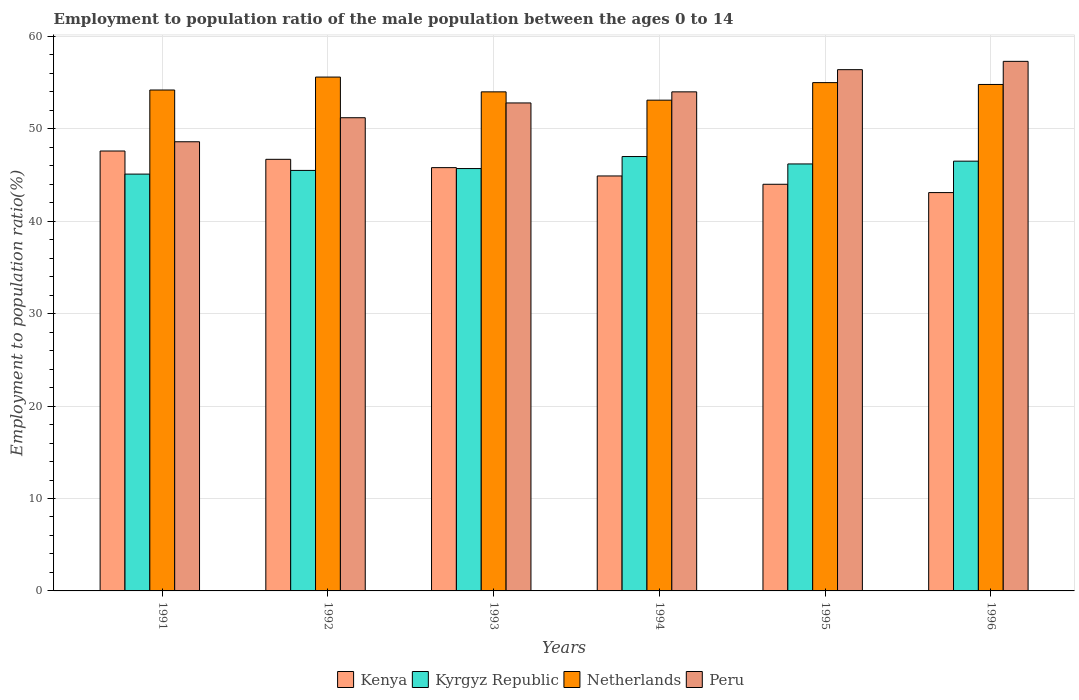How many bars are there on the 4th tick from the left?
Keep it short and to the point. 4. What is the label of the 2nd group of bars from the left?
Your response must be concise. 1992. In how many cases, is the number of bars for a given year not equal to the number of legend labels?
Provide a short and direct response. 0. What is the employment to population ratio in Kyrgyz Republic in 1992?
Provide a succinct answer. 45.5. Across all years, what is the maximum employment to population ratio in Netherlands?
Your answer should be compact. 55.6. Across all years, what is the minimum employment to population ratio in Kyrgyz Republic?
Your answer should be compact. 45.1. What is the total employment to population ratio in Kyrgyz Republic in the graph?
Keep it short and to the point. 276. What is the difference between the employment to population ratio in Netherlands in 1994 and that in 1995?
Your answer should be compact. -1.9. What is the difference between the employment to population ratio in Peru in 1992 and the employment to population ratio in Kyrgyz Republic in 1993?
Keep it short and to the point. 5.5. What is the average employment to population ratio in Kenya per year?
Offer a terse response. 45.35. In the year 1994, what is the difference between the employment to population ratio in Kenya and employment to population ratio in Netherlands?
Your answer should be compact. -8.2. In how many years, is the employment to population ratio in Kenya greater than 36 %?
Provide a succinct answer. 6. What is the ratio of the employment to population ratio in Peru in 1992 to that in 1996?
Provide a short and direct response. 0.89. Is the employment to population ratio in Kyrgyz Republic in 1991 less than that in 1994?
Your answer should be compact. Yes. Is the difference between the employment to population ratio in Kenya in 1995 and 1996 greater than the difference between the employment to population ratio in Netherlands in 1995 and 1996?
Offer a terse response. Yes. What is the difference between the highest and the second highest employment to population ratio in Peru?
Keep it short and to the point. 0.9. What is the difference between the highest and the lowest employment to population ratio in Peru?
Your response must be concise. 8.7. Is the sum of the employment to population ratio in Netherlands in 1995 and 1996 greater than the maximum employment to population ratio in Peru across all years?
Offer a terse response. Yes. Is it the case that in every year, the sum of the employment to population ratio in Kenya and employment to population ratio in Netherlands is greater than the sum of employment to population ratio in Kyrgyz Republic and employment to population ratio in Peru?
Keep it short and to the point. No. What does the 3rd bar from the left in 1994 represents?
Your response must be concise. Netherlands. What does the 1st bar from the right in 1993 represents?
Make the answer very short. Peru. What is the difference between two consecutive major ticks on the Y-axis?
Keep it short and to the point. 10. Are the values on the major ticks of Y-axis written in scientific E-notation?
Provide a short and direct response. No. Where does the legend appear in the graph?
Provide a succinct answer. Bottom center. How are the legend labels stacked?
Your response must be concise. Horizontal. What is the title of the graph?
Ensure brevity in your answer.  Employment to population ratio of the male population between the ages 0 to 14. Does "St. Vincent and the Grenadines" appear as one of the legend labels in the graph?
Your answer should be very brief. No. What is the label or title of the Y-axis?
Provide a short and direct response. Employment to population ratio(%). What is the Employment to population ratio(%) of Kenya in 1991?
Your response must be concise. 47.6. What is the Employment to population ratio(%) in Kyrgyz Republic in 1991?
Ensure brevity in your answer.  45.1. What is the Employment to population ratio(%) of Netherlands in 1991?
Offer a terse response. 54.2. What is the Employment to population ratio(%) in Peru in 1991?
Make the answer very short. 48.6. What is the Employment to population ratio(%) in Kenya in 1992?
Provide a short and direct response. 46.7. What is the Employment to population ratio(%) in Kyrgyz Republic in 1992?
Ensure brevity in your answer.  45.5. What is the Employment to population ratio(%) of Netherlands in 1992?
Give a very brief answer. 55.6. What is the Employment to population ratio(%) of Peru in 1992?
Provide a succinct answer. 51.2. What is the Employment to population ratio(%) of Kenya in 1993?
Provide a succinct answer. 45.8. What is the Employment to population ratio(%) of Kyrgyz Republic in 1993?
Keep it short and to the point. 45.7. What is the Employment to population ratio(%) in Netherlands in 1993?
Offer a very short reply. 54. What is the Employment to population ratio(%) of Peru in 1993?
Make the answer very short. 52.8. What is the Employment to population ratio(%) in Kenya in 1994?
Ensure brevity in your answer.  44.9. What is the Employment to population ratio(%) of Netherlands in 1994?
Provide a short and direct response. 53.1. What is the Employment to population ratio(%) in Peru in 1994?
Provide a succinct answer. 54. What is the Employment to population ratio(%) of Kenya in 1995?
Your answer should be very brief. 44. What is the Employment to population ratio(%) of Kyrgyz Republic in 1995?
Give a very brief answer. 46.2. What is the Employment to population ratio(%) of Peru in 1995?
Make the answer very short. 56.4. What is the Employment to population ratio(%) in Kenya in 1996?
Provide a short and direct response. 43.1. What is the Employment to population ratio(%) of Kyrgyz Republic in 1996?
Offer a terse response. 46.5. What is the Employment to population ratio(%) in Netherlands in 1996?
Keep it short and to the point. 54.8. What is the Employment to population ratio(%) in Peru in 1996?
Give a very brief answer. 57.3. Across all years, what is the maximum Employment to population ratio(%) in Kenya?
Give a very brief answer. 47.6. Across all years, what is the maximum Employment to population ratio(%) of Netherlands?
Your response must be concise. 55.6. Across all years, what is the maximum Employment to population ratio(%) of Peru?
Make the answer very short. 57.3. Across all years, what is the minimum Employment to population ratio(%) of Kenya?
Provide a succinct answer. 43.1. Across all years, what is the minimum Employment to population ratio(%) in Kyrgyz Republic?
Provide a succinct answer. 45.1. Across all years, what is the minimum Employment to population ratio(%) in Netherlands?
Ensure brevity in your answer.  53.1. Across all years, what is the minimum Employment to population ratio(%) in Peru?
Keep it short and to the point. 48.6. What is the total Employment to population ratio(%) in Kenya in the graph?
Ensure brevity in your answer.  272.1. What is the total Employment to population ratio(%) in Kyrgyz Republic in the graph?
Your response must be concise. 276. What is the total Employment to population ratio(%) of Netherlands in the graph?
Provide a short and direct response. 326.7. What is the total Employment to population ratio(%) of Peru in the graph?
Ensure brevity in your answer.  320.3. What is the difference between the Employment to population ratio(%) of Kenya in 1991 and that in 1992?
Offer a terse response. 0.9. What is the difference between the Employment to population ratio(%) of Kyrgyz Republic in 1991 and that in 1992?
Keep it short and to the point. -0.4. What is the difference between the Employment to population ratio(%) in Netherlands in 1991 and that in 1992?
Make the answer very short. -1.4. What is the difference between the Employment to population ratio(%) in Peru in 1991 and that in 1992?
Make the answer very short. -2.6. What is the difference between the Employment to population ratio(%) of Netherlands in 1991 and that in 1993?
Your answer should be compact. 0.2. What is the difference between the Employment to population ratio(%) in Kenya in 1991 and that in 1994?
Keep it short and to the point. 2.7. What is the difference between the Employment to population ratio(%) in Kenya in 1991 and that in 1995?
Your answer should be very brief. 3.6. What is the difference between the Employment to population ratio(%) in Kyrgyz Republic in 1991 and that in 1995?
Keep it short and to the point. -1.1. What is the difference between the Employment to population ratio(%) in Netherlands in 1991 and that in 1995?
Give a very brief answer. -0.8. What is the difference between the Employment to population ratio(%) of Peru in 1991 and that in 1995?
Your response must be concise. -7.8. What is the difference between the Employment to population ratio(%) in Peru in 1991 and that in 1996?
Give a very brief answer. -8.7. What is the difference between the Employment to population ratio(%) of Peru in 1992 and that in 1993?
Keep it short and to the point. -1.6. What is the difference between the Employment to population ratio(%) in Kenya in 1992 and that in 1994?
Your answer should be very brief. 1.8. What is the difference between the Employment to population ratio(%) of Peru in 1992 and that in 1994?
Ensure brevity in your answer.  -2.8. What is the difference between the Employment to population ratio(%) of Kenya in 1992 and that in 1995?
Ensure brevity in your answer.  2.7. What is the difference between the Employment to population ratio(%) in Kenya in 1992 and that in 1996?
Offer a very short reply. 3.6. What is the difference between the Employment to population ratio(%) of Kyrgyz Republic in 1992 and that in 1996?
Your response must be concise. -1. What is the difference between the Employment to population ratio(%) in Kenya in 1993 and that in 1994?
Your response must be concise. 0.9. What is the difference between the Employment to population ratio(%) of Kyrgyz Republic in 1993 and that in 1994?
Your response must be concise. -1.3. What is the difference between the Employment to population ratio(%) of Peru in 1993 and that in 1994?
Offer a very short reply. -1.2. What is the difference between the Employment to population ratio(%) of Netherlands in 1993 and that in 1995?
Make the answer very short. -1. What is the difference between the Employment to population ratio(%) in Kenya in 1993 and that in 1996?
Provide a short and direct response. 2.7. What is the difference between the Employment to population ratio(%) of Kyrgyz Republic in 1993 and that in 1996?
Keep it short and to the point. -0.8. What is the difference between the Employment to population ratio(%) of Kyrgyz Republic in 1994 and that in 1995?
Provide a succinct answer. 0.8. What is the difference between the Employment to population ratio(%) of Netherlands in 1994 and that in 1996?
Offer a terse response. -1.7. What is the difference between the Employment to population ratio(%) in Peru in 1994 and that in 1996?
Make the answer very short. -3.3. What is the difference between the Employment to population ratio(%) of Kyrgyz Republic in 1995 and that in 1996?
Give a very brief answer. -0.3. What is the difference between the Employment to population ratio(%) of Peru in 1995 and that in 1996?
Ensure brevity in your answer.  -0.9. What is the difference between the Employment to population ratio(%) of Kenya in 1991 and the Employment to population ratio(%) of Netherlands in 1992?
Keep it short and to the point. -8. What is the difference between the Employment to population ratio(%) of Kenya in 1991 and the Employment to population ratio(%) of Peru in 1993?
Offer a very short reply. -5.2. What is the difference between the Employment to population ratio(%) in Kyrgyz Republic in 1991 and the Employment to population ratio(%) in Netherlands in 1993?
Ensure brevity in your answer.  -8.9. What is the difference between the Employment to population ratio(%) in Netherlands in 1991 and the Employment to population ratio(%) in Peru in 1993?
Make the answer very short. 1.4. What is the difference between the Employment to population ratio(%) in Kenya in 1991 and the Employment to population ratio(%) in Peru in 1994?
Your response must be concise. -6.4. What is the difference between the Employment to population ratio(%) in Kyrgyz Republic in 1991 and the Employment to population ratio(%) in Peru in 1994?
Your answer should be compact. -8.9. What is the difference between the Employment to population ratio(%) in Netherlands in 1991 and the Employment to population ratio(%) in Peru in 1994?
Your answer should be compact. 0.2. What is the difference between the Employment to population ratio(%) of Kenya in 1991 and the Employment to population ratio(%) of Kyrgyz Republic in 1995?
Give a very brief answer. 1.4. What is the difference between the Employment to population ratio(%) in Netherlands in 1991 and the Employment to population ratio(%) in Peru in 1995?
Make the answer very short. -2.2. What is the difference between the Employment to population ratio(%) in Kenya in 1991 and the Employment to population ratio(%) in Netherlands in 1996?
Offer a terse response. -7.2. What is the difference between the Employment to population ratio(%) in Kenya in 1991 and the Employment to population ratio(%) in Peru in 1996?
Give a very brief answer. -9.7. What is the difference between the Employment to population ratio(%) in Kyrgyz Republic in 1991 and the Employment to population ratio(%) in Peru in 1996?
Ensure brevity in your answer.  -12.2. What is the difference between the Employment to population ratio(%) of Netherlands in 1991 and the Employment to population ratio(%) of Peru in 1996?
Ensure brevity in your answer.  -3.1. What is the difference between the Employment to population ratio(%) in Kenya in 1992 and the Employment to population ratio(%) in Netherlands in 1993?
Ensure brevity in your answer.  -7.3. What is the difference between the Employment to population ratio(%) of Kyrgyz Republic in 1992 and the Employment to population ratio(%) of Netherlands in 1993?
Make the answer very short. -8.5. What is the difference between the Employment to population ratio(%) in Netherlands in 1992 and the Employment to population ratio(%) in Peru in 1993?
Provide a short and direct response. 2.8. What is the difference between the Employment to population ratio(%) of Kenya in 1992 and the Employment to population ratio(%) of Kyrgyz Republic in 1994?
Provide a short and direct response. -0.3. What is the difference between the Employment to population ratio(%) in Kyrgyz Republic in 1992 and the Employment to population ratio(%) in Netherlands in 1995?
Keep it short and to the point. -9.5. What is the difference between the Employment to population ratio(%) of Netherlands in 1992 and the Employment to population ratio(%) of Peru in 1995?
Your response must be concise. -0.8. What is the difference between the Employment to population ratio(%) in Kenya in 1992 and the Employment to population ratio(%) in Kyrgyz Republic in 1996?
Offer a very short reply. 0.2. What is the difference between the Employment to population ratio(%) in Kyrgyz Republic in 1992 and the Employment to population ratio(%) in Peru in 1996?
Ensure brevity in your answer.  -11.8. What is the difference between the Employment to population ratio(%) in Kyrgyz Republic in 1993 and the Employment to population ratio(%) in Peru in 1994?
Provide a succinct answer. -8.3. What is the difference between the Employment to population ratio(%) in Netherlands in 1993 and the Employment to population ratio(%) in Peru in 1994?
Provide a succinct answer. 0. What is the difference between the Employment to population ratio(%) of Kenya in 1993 and the Employment to population ratio(%) of Kyrgyz Republic in 1995?
Make the answer very short. -0.4. What is the difference between the Employment to population ratio(%) of Kenya in 1993 and the Employment to population ratio(%) of Peru in 1995?
Offer a very short reply. -10.6. What is the difference between the Employment to population ratio(%) of Kyrgyz Republic in 1993 and the Employment to population ratio(%) of Peru in 1995?
Keep it short and to the point. -10.7. What is the difference between the Employment to population ratio(%) of Kenya in 1993 and the Employment to population ratio(%) of Peru in 1996?
Provide a succinct answer. -11.5. What is the difference between the Employment to population ratio(%) in Netherlands in 1993 and the Employment to population ratio(%) in Peru in 1996?
Provide a succinct answer. -3.3. What is the difference between the Employment to population ratio(%) in Kenya in 1994 and the Employment to population ratio(%) in Kyrgyz Republic in 1995?
Your answer should be very brief. -1.3. What is the difference between the Employment to population ratio(%) in Kenya in 1994 and the Employment to population ratio(%) in Netherlands in 1995?
Your response must be concise. -10.1. What is the difference between the Employment to population ratio(%) of Kyrgyz Republic in 1994 and the Employment to population ratio(%) of Netherlands in 1995?
Keep it short and to the point. -8. What is the difference between the Employment to population ratio(%) in Kyrgyz Republic in 1994 and the Employment to population ratio(%) in Peru in 1995?
Offer a very short reply. -9.4. What is the difference between the Employment to population ratio(%) of Netherlands in 1994 and the Employment to population ratio(%) of Peru in 1995?
Make the answer very short. -3.3. What is the difference between the Employment to population ratio(%) of Kenya in 1994 and the Employment to population ratio(%) of Kyrgyz Republic in 1996?
Your answer should be compact. -1.6. What is the difference between the Employment to population ratio(%) in Kenya in 1994 and the Employment to population ratio(%) in Peru in 1996?
Ensure brevity in your answer.  -12.4. What is the difference between the Employment to population ratio(%) of Kyrgyz Republic in 1994 and the Employment to population ratio(%) of Netherlands in 1996?
Provide a short and direct response. -7.8. What is the difference between the Employment to population ratio(%) in Netherlands in 1994 and the Employment to population ratio(%) in Peru in 1996?
Provide a succinct answer. -4.2. What is the difference between the Employment to population ratio(%) in Kenya in 1995 and the Employment to population ratio(%) in Kyrgyz Republic in 1996?
Ensure brevity in your answer.  -2.5. What is the difference between the Employment to population ratio(%) in Kenya in 1995 and the Employment to population ratio(%) in Peru in 1996?
Offer a terse response. -13.3. What is the average Employment to population ratio(%) in Kenya per year?
Your response must be concise. 45.35. What is the average Employment to population ratio(%) of Netherlands per year?
Your response must be concise. 54.45. What is the average Employment to population ratio(%) in Peru per year?
Ensure brevity in your answer.  53.38. In the year 1991, what is the difference between the Employment to population ratio(%) in Kenya and Employment to population ratio(%) in Kyrgyz Republic?
Give a very brief answer. 2.5. In the year 1991, what is the difference between the Employment to population ratio(%) of Kenya and Employment to population ratio(%) of Netherlands?
Make the answer very short. -6.6. In the year 1991, what is the difference between the Employment to population ratio(%) of Kenya and Employment to population ratio(%) of Peru?
Ensure brevity in your answer.  -1. In the year 1992, what is the difference between the Employment to population ratio(%) in Kyrgyz Republic and Employment to population ratio(%) in Netherlands?
Make the answer very short. -10.1. In the year 1992, what is the difference between the Employment to population ratio(%) in Kyrgyz Republic and Employment to population ratio(%) in Peru?
Offer a very short reply. -5.7. In the year 1992, what is the difference between the Employment to population ratio(%) of Netherlands and Employment to population ratio(%) of Peru?
Offer a very short reply. 4.4. In the year 1993, what is the difference between the Employment to population ratio(%) of Kenya and Employment to population ratio(%) of Kyrgyz Republic?
Offer a very short reply. 0.1. In the year 1993, what is the difference between the Employment to population ratio(%) of Kyrgyz Republic and Employment to population ratio(%) of Netherlands?
Offer a terse response. -8.3. In the year 1994, what is the difference between the Employment to population ratio(%) of Netherlands and Employment to population ratio(%) of Peru?
Your answer should be compact. -0.9. In the year 1995, what is the difference between the Employment to population ratio(%) in Kenya and Employment to population ratio(%) in Kyrgyz Republic?
Ensure brevity in your answer.  -2.2. In the year 1995, what is the difference between the Employment to population ratio(%) of Kenya and Employment to population ratio(%) of Peru?
Give a very brief answer. -12.4. In the year 1995, what is the difference between the Employment to population ratio(%) in Kyrgyz Republic and Employment to population ratio(%) in Netherlands?
Keep it short and to the point. -8.8. In the year 1995, what is the difference between the Employment to population ratio(%) in Kyrgyz Republic and Employment to population ratio(%) in Peru?
Keep it short and to the point. -10.2. In the year 1996, what is the difference between the Employment to population ratio(%) of Kenya and Employment to population ratio(%) of Kyrgyz Republic?
Give a very brief answer. -3.4. In the year 1996, what is the difference between the Employment to population ratio(%) of Kenya and Employment to population ratio(%) of Peru?
Make the answer very short. -14.2. In the year 1996, what is the difference between the Employment to population ratio(%) of Kyrgyz Republic and Employment to population ratio(%) of Peru?
Keep it short and to the point. -10.8. What is the ratio of the Employment to population ratio(%) in Kenya in 1991 to that in 1992?
Offer a very short reply. 1.02. What is the ratio of the Employment to population ratio(%) in Netherlands in 1991 to that in 1992?
Provide a succinct answer. 0.97. What is the ratio of the Employment to population ratio(%) of Peru in 1991 to that in 1992?
Your answer should be compact. 0.95. What is the ratio of the Employment to population ratio(%) in Kenya in 1991 to that in 1993?
Offer a very short reply. 1.04. What is the ratio of the Employment to population ratio(%) in Kyrgyz Republic in 1991 to that in 1993?
Provide a succinct answer. 0.99. What is the ratio of the Employment to population ratio(%) in Peru in 1991 to that in 1993?
Offer a terse response. 0.92. What is the ratio of the Employment to population ratio(%) in Kenya in 1991 to that in 1994?
Provide a short and direct response. 1.06. What is the ratio of the Employment to population ratio(%) of Kyrgyz Republic in 1991 to that in 1994?
Ensure brevity in your answer.  0.96. What is the ratio of the Employment to population ratio(%) in Netherlands in 1991 to that in 1994?
Offer a very short reply. 1.02. What is the ratio of the Employment to population ratio(%) of Kenya in 1991 to that in 1995?
Keep it short and to the point. 1.08. What is the ratio of the Employment to population ratio(%) in Kyrgyz Republic in 1991 to that in 1995?
Offer a terse response. 0.98. What is the ratio of the Employment to population ratio(%) of Netherlands in 1991 to that in 1995?
Offer a very short reply. 0.99. What is the ratio of the Employment to population ratio(%) in Peru in 1991 to that in 1995?
Offer a very short reply. 0.86. What is the ratio of the Employment to population ratio(%) in Kenya in 1991 to that in 1996?
Make the answer very short. 1.1. What is the ratio of the Employment to population ratio(%) in Kyrgyz Republic in 1991 to that in 1996?
Provide a short and direct response. 0.97. What is the ratio of the Employment to population ratio(%) of Netherlands in 1991 to that in 1996?
Your answer should be very brief. 0.99. What is the ratio of the Employment to population ratio(%) of Peru in 1991 to that in 1996?
Your answer should be very brief. 0.85. What is the ratio of the Employment to population ratio(%) of Kenya in 1992 to that in 1993?
Offer a terse response. 1.02. What is the ratio of the Employment to population ratio(%) in Kyrgyz Republic in 1992 to that in 1993?
Keep it short and to the point. 1. What is the ratio of the Employment to population ratio(%) of Netherlands in 1992 to that in 1993?
Ensure brevity in your answer.  1.03. What is the ratio of the Employment to population ratio(%) of Peru in 1992 to that in 1993?
Your answer should be very brief. 0.97. What is the ratio of the Employment to population ratio(%) of Kenya in 1992 to that in 1994?
Your answer should be very brief. 1.04. What is the ratio of the Employment to population ratio(%) in Kyrgyz Republic in 1992 to that in 1994?
Provide a short and direct response. 0.97. What is the ratio of the Employment to population ratio(%) of Netherlands in 1992 to that in 1994?
Offer a terse response. 1.05. What is the ratio of the Employment to population ratio(%) in Peru in 1992 to that in 1994?
Offer a very short reply. 0.95. What is the ratio of the Employment to population ratio(%) in Kenya in 1992 to that in 1995?
Your answer should be compact. 1.06. What is the ratio of the Employment to population ratio(%) of Netherlands in 1992 to that in 1995?
Keep it short and to the point. 1.01. What is the ratio of the Employment to population ratio(%) of Peru in 1992 to that in 1995?
Give a very brief answer. 0.91. What is the ratio of the Employment to population ratio(%) of Kenya in 1992 to that in 1996?
Your answer should be compact. 1.08. What is the ratio of the Employment to population ratio(%) of Kyrgyz Republic in 1992 to that in 1996?
Provide a succinct answer. 0.98. What is the ratio of the Employment to population ratio(%) of Netherlands in 1992 to that in 1996?
Keep it short and to the point. 1.01. What is the ratio of the Employment to population ratio(%) in Peru in 1992 to that in 1996?
Offer a very short reply. 0.89. What is the ratio of the Employment to population ratio(%) of Kenya in 1993 to that in 1994?
Your response must be concise. 1.02. What is the ratio of the Employment to population ratio(%) in Kyrgyz Republic in 1993 to that in 1994?
Offer a terse response. 0.97. What is the ratio of the Employment to population ratio(%) in Netherlands in 1993 to that in 1994?
Make the answer very short. 1.02. What is the ratio of the Employment to population ratio(%) of Peru in 1993 to that in 1994?
Your response must be concise. 0.98. What is the ratio of the Employment to population ratio(%) of Kenya in 1993 to that in 1995?
Make the answer very short. 1.04. What is the ratio of the Employment to population ratio(%) in Netherlands in 1993 to that in 1995?
Keep it short and to the point. 0.98. What is the ratio of the Employment to population ratio(%) of Peru in 1993 to that in 1995?
Your response must be concise. 0.94. What is the ratio of the Employment to population ratio(%) of Kenya in 1993 to that in 1996?
Your response must be concise. 1.06. What is the ratio of the Employment to population ratio(%) in Kyrgyz Republic in 1993 to that in 1996?
Your response must be concise. 0.98. What is the ratio of the Employment to population ratio(%) of Netherlands in 1993 to that in 1996?
Offer a terse response. 0.99. What is the ratio of the Employment to population ratio(%) in Peru in 1993 to that in 1996?
Provide a short and direct response. 0.92. What is the ratio of the Employment to population ratio(%) of Kenya in 1994 to that in 1995?
Your answer should be very brief. 1.02. What is the ratio of the Employment to population ratio(%) in Kyrgyz Republic in 1994 to that in 1995?
Offer a terse response. 1.02. What is the ratio of the Employment to population ratio(%) in Netherlands in 1994 to that in 1995?
Your answer should be compact. 0.97. What is the ratio of the Employment to population ratio(%) of Peru in 1994 to that in 1995?
Give a very brief answer. 0.96. What is the ratio of the Employment to population ratio(%) in Kenya in 1994 to that in 1996?
Provide a succinct answer. 1.04. What is the ratio of the Employment to population ratio(%) of Kyrgyz Republic in 1994 to that in 1996?
Your response must be concise. 1.01. What is the ratio of the Employment to population ratio(%) in Peru in 1994 to that in 1996?
Your answer should be compact. 0.94. What is the ratio of the Employment to population ratio(%) of Kenya in 1995 to that in 1996?
Give a very brief answer. 1.02. What is the ratio of the Employment to population ratio(%) of Kyrgyz Republic in 1995 to that in 1996?
Ensure brevity in your answer.  0.99. What is the ratio of the Employment to population ratio(%) of Peru in 1995 to that in 1996?
Provide a succinct answer. 0.98. What is the difference between the highest and the lowest Employment to population ratio(%) of Kenya?
Your answer should be compact. 4.5. What is the difference between the highest and the lowest Employment to population ratio(%) in Netherlands?
Your answer should be compact. 2.5. What is the difference between the highest and the lowest Employment to population ratio(%) in Peru?
Your answer should be very brief. 8.7. 